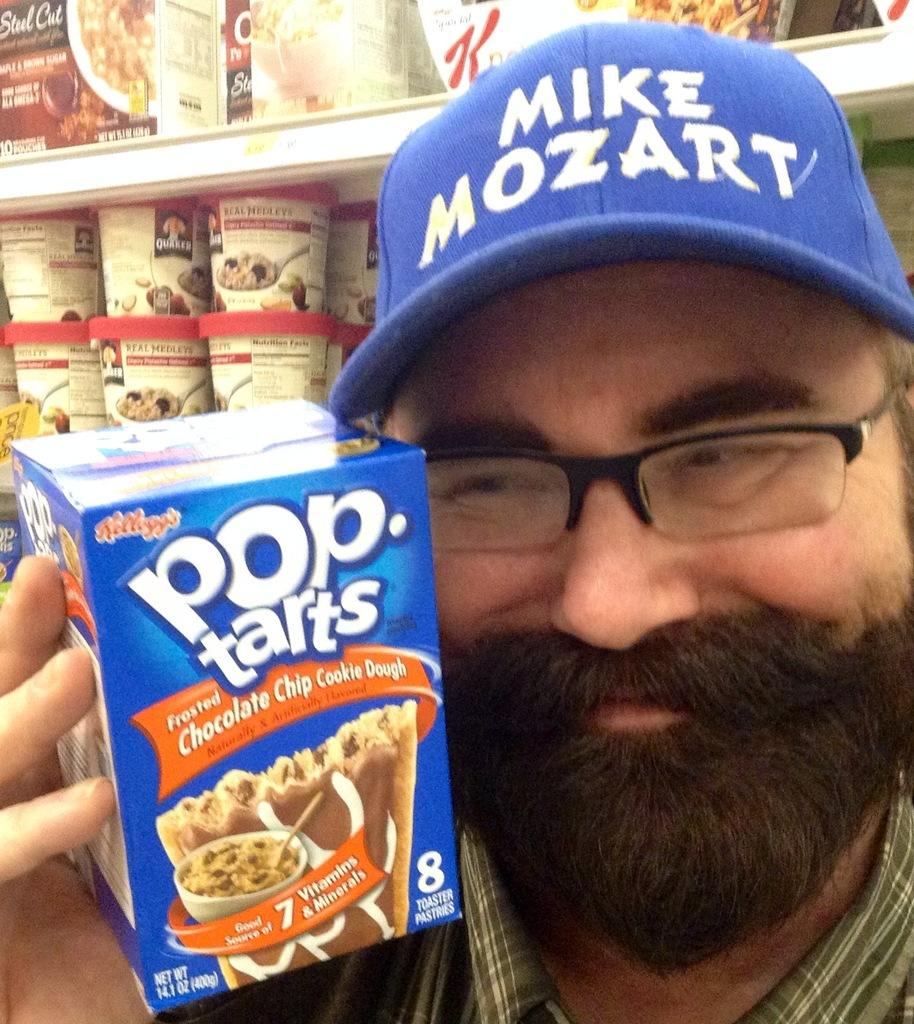Who is present in the image? There is a man in the image. What is the man holding in his hand? The man is holding a food item in his hand. Can you describe the man's attire? The man is wearing a blue hat. What is the man's facial expression? The man is smiling. What can be seen in the background of the image? There are cookies visible in the background of the image. How does the man blow the crowd away in the image? There is no crowd present in the image, and the man is not blowing anything away. 